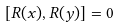Convert formula to latex. <formula><loc_0><loc_0><loc_500><loc_500>[ R ( x ) , R ( y ) ] & = 0</formula> 